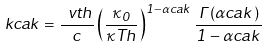Convert formula to latex. <formula><loc_0><loc_0><loc_500><loc_500>\ k c a k = \frac { \ v t h } { c } \left ( \frac { \kappa _ { 0 } } { \kappa T h } \right ) ^ { 1 - \alpha c a k } \frac { \Gamma ( \alpha c a k ) } { 1 - \alpha c a k }</formula> 